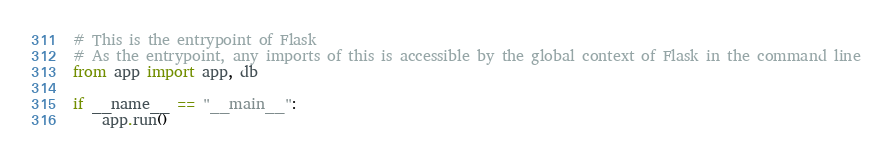Convert code to text. <code><loc_0><loc_0><loc_500><loc_500><_Python_># This is the entrypoint of Flask
# As the entrypoint, any imports of this is accessible by the global context of Flask in the command line
from app import app, db

if __name__ == "__main__":
    app.run()</code> 